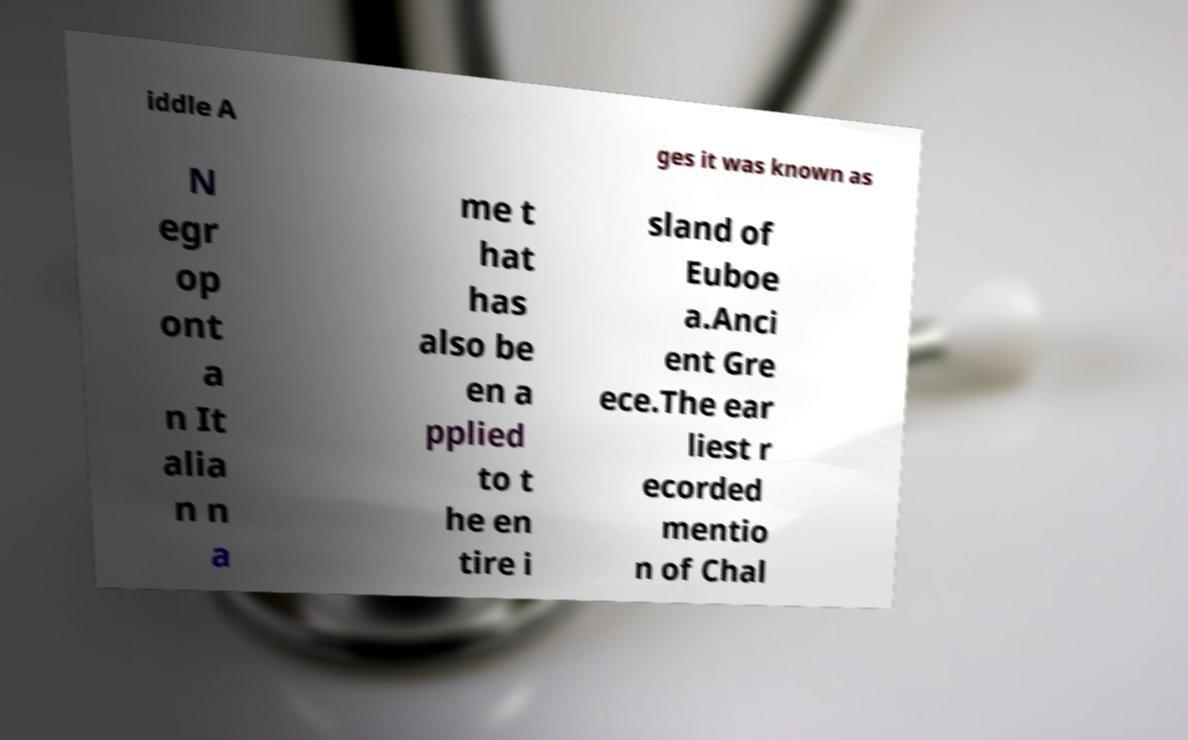Please identify and transcribe the text found in this image. iddle A ges it was known as N egr op ont a n It alia n n a me t hat has also be en a pplied to t he en tire i sland of Euboe a.Anci ent Gre ece.The ear liest r ecorded mentio n of Chal 